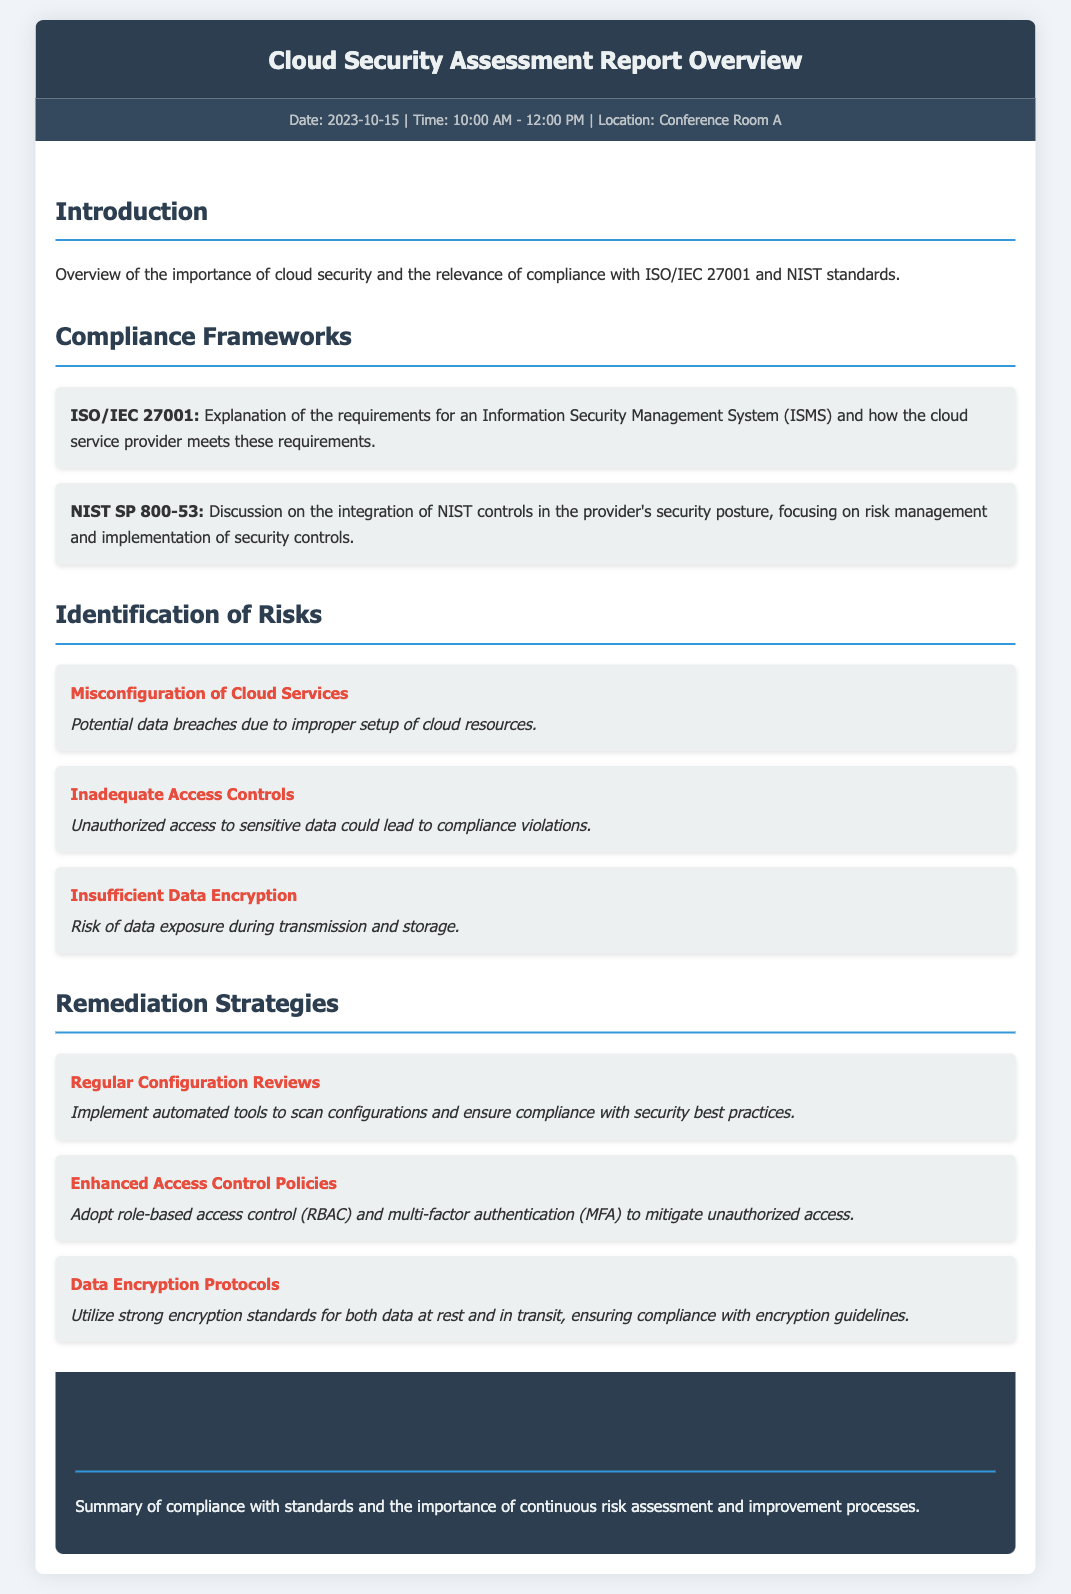What is the date of the report? The date of the report is mentioned in the meta-info section.
Answer: 2023-10-15 What are the compliance frameworks discussed in the report? The compliance frameworks section lists the key frameworks related to cloud security compliance.
Answer: ISO/IEC 27001 and NIST SP 800-53 What risk is associated with inadequate access controls? The impact of inadequate access controls is stated under the identified risks in the document.
Answer: Unauthorized access to sensitive data could lead to compliance violations How many risks are identified in the report? The number of risks can be counted in the Identification of Risks section.
Answer: Three What remediation strategy involves automated tools? The specific remediation strategy that mentions automated tools is in the Remediation Strategies section.
Answer: Regular Configuration Reviews What is the time span of the report meeting? The time of the meeting is provided in the meta-info section.
Answer: 10:00 AM - 12:00 PM What is the main focus of the conclusion section? The conclusion summarizes the overall compliance and its significance.
Answer: Continuous risk assessment and improvement processes Which encryption protocols are mentioned for data protection? The Data Encryption Protocols strategy in the Remediation Strategies section details this aspect.
Answer: Strong encryption standards for both data at rest and in transit 